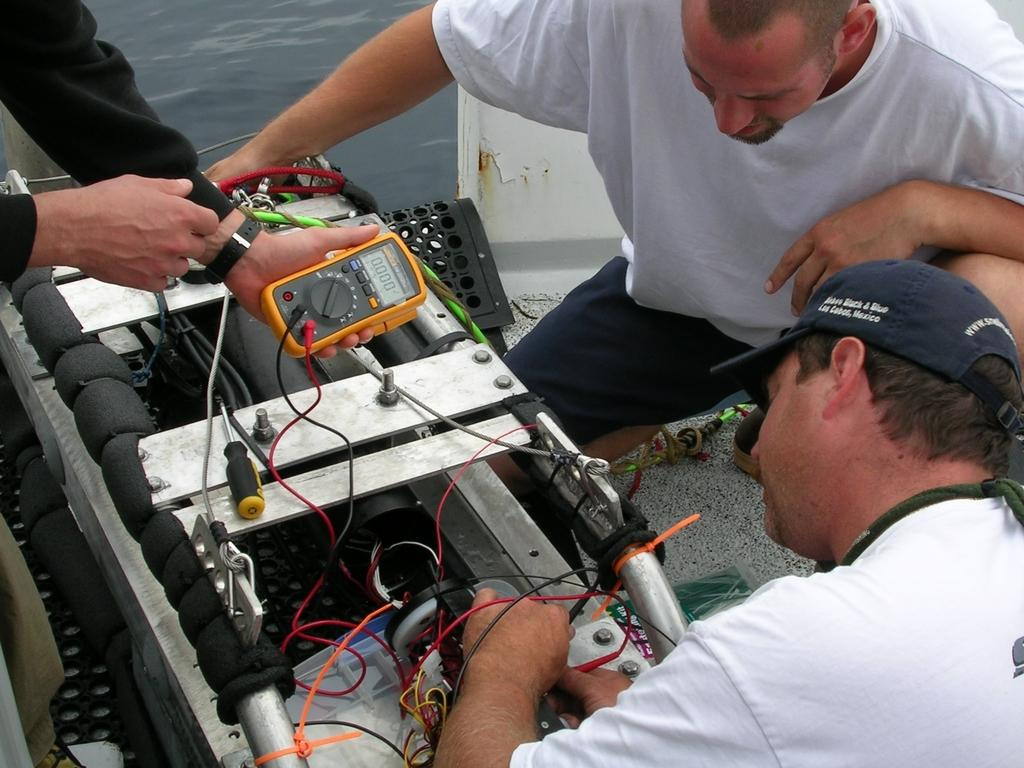Who is present in the image? There are people in the image. What are some of the men wearing? Some men in the image are wearing white t-shirts. What type of equipment can be seen in the image? There are electronic machines in the image. What is the color of the object held by one of the people? There is a yellow object in a person's hand. What type of jam is being spread on the electronic machines in the image? There is no jam present in the image, and the electronic machines are not being used for spreading jam. 